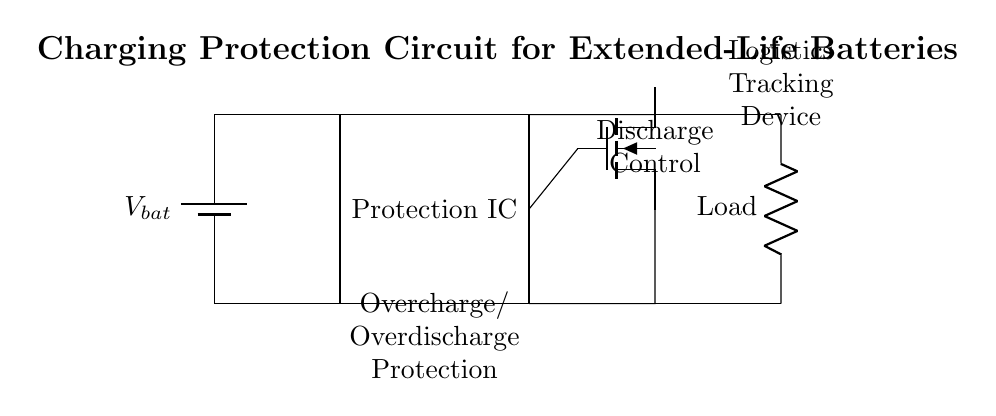What type of protection does this circuit offer? The circuit is designed for overcharge and overdischarge protection, indicating that it safeguards the battery from conditions that could shorten its lifespan. This is evident from the labeled section in the circuit that specifies "Overcharge/Overdischarge Protection".
Answer: Overcharge and overdischarge protection What component controls discharge in the circuit? The discharge control is handled by the MOSFET, which is identified in the circuit diagram as the component labeled "Discharge Control". The current flow to the load is regulated by this MOSFET.
Answer: MOSFET How many main components are in the circuit? The circuit has four main components: the battery, the protection IC, the MOSFET, and the load resistor. By counting the labeled and important parts in the diagram, we can clearly identify these four.
Answer: Four What does the load in this circuit represent? The load represents the logistics tracking device, which is a critical application for the circuit. It is labeled directly as such in the diagram, connecting the circuit functionality to its practical use in logistics.
Answer: Logistics tracking device How does this circuit prevent battery damage? The circuit prevents battery damage by incorporating both overcharge and overdischarge protection features. The protection IC monitors battery levels and controls the MOSFET to disconnect the load when the battery reaches unsafe levels. This reasoning combines knowledge of circuit protection principles with the explicit functions labeled in the diagram.
Answer: By using overcharge and overdischarge protection 